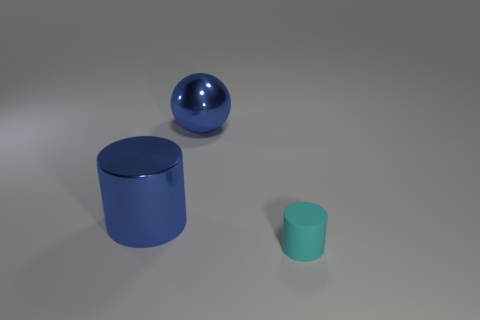There is a blue metal thing that is the same shape as the cyan object; what size is it?
Keep it short and to the point. Large. Is the color of the big cylinder the same as the metal ball?
Your answer should be compact. Yes. How many large shiny cylinders are the same color as the metallic sphere?
Make the answer very short. 1. Does the cylinder left of the small matte cylinder have the same color as the metallic sphere?
Give a very brief answer. Yes. What number of other objects are the same size as the blue metal sphere?
Give a very brief answer. 1. There is a cylinder that is behind the cyan matte cylinder; is its color the same as the rubber object that is in front of the big metallic ball?
Give a very brief answer. No. There is a large cylinder; what number of big spheres are in front of it?
Your response must be concise. 0. There is a cylinder that is behind the object that is in front of the large blue cylinder; are there any large metal objects that are behind it?
Your answer should be very brief. Yes. How many shiny objects are the same size as the blue metallic ball?
Your response must be concise. 1. There is a cylinder on the left side of the cylinder that is to the right of the big metal cylinder; what is its material?
Keep it short and to the point. Metal. 